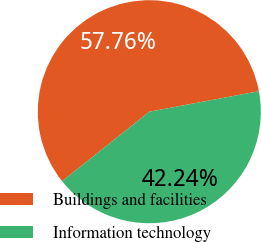Convert chart. <chart><loc_0><loc_0><loc_500><loc_500><pie_chart><fcel>Buildings and facilities<fcel>Information technology<nl><fcel>57.76%<fcel>42.24%<nl></chart> 